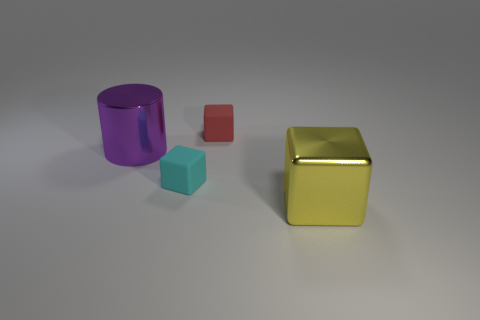Is there anything else that is the same shape as the large yellow thing?
Your answer should be very brief. Yes. What is the color of the other tiny rubber thing that is the same shape as the small cyan rubber object?
Your response must be concise. Red. Do the small red rubber object and the shiny object in front of the tiny cyan cube have the same shape?
Provide a short and direct response. Yes. What number of things are either objects left of the big block or cubes that are behind the purple thing?
Keep it short and to the point. 3. What is the material of the large yellow object?
Give a very brief answer. Metal. What number of other things are there of the same size as the purple object?
Provide a succinct answer. 1. There is a rubber thing that is to the left of the red thing; what is its size?
Your response must be concise. Small. There is a large cylinder to the left of the big metal thing to the right of the metallic thing that is on the left side of the big yellow block; what is its material?
Provide a short and direct response. Metal. Is the red thing the same shape as the big purple metallic thing?
Give a very brief answer. No. What number of rubber objects are either brown cylinders or yellow objects?
Keep it short and to the point. 0. 